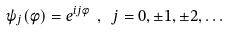<formula> <loc_0><loc_0><loc_500><loc_500>\psi _ { j } ( \phi ) = e ^ { i j \phi } \ , \ j = 0 , \pm 1 , \pm 2 , \dots</formula> 